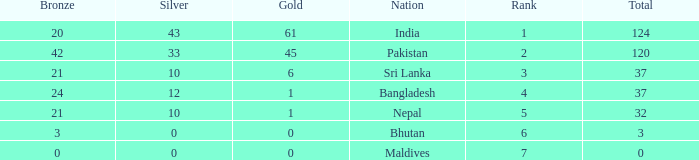Could you parse the entire table as a dict? {'header': ['Bronze', 'Silver', 'Gold', 'Nation', 'Rank', 'Total'], 'rows': [['20', '43', '61', 'India', '1', '124'], ['42', '33', '45', 'Pakistan', '2', '120'], ['21', '10', '6', 'Sri Lanka', '3', '37'], ['24', '12', '1', 'Bangladesh', '4', '37'], ['21', '10', '1', 'Nepal', '5', '32'], ['3', '0', '0', 'Bhutan', '6', '3'], ['0', '0', '0', 'Maldives', '7', '0']]} How much Silver has a Rank of 7? 1.0. 